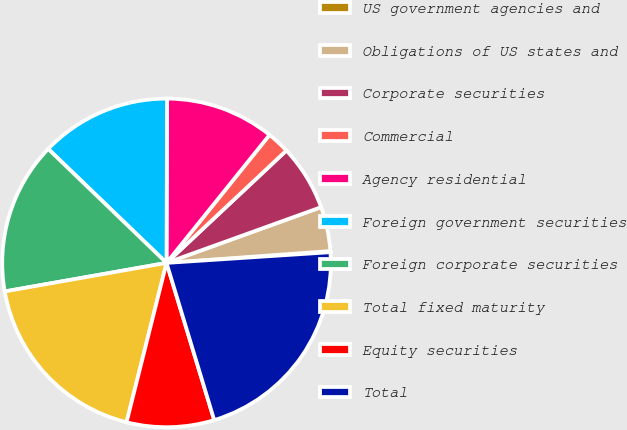<chart> <loc_0><loc_0><loc_500><loc_500><pie_chart><fcel>US government agencies and<fcel>Obligations of US states and<fcel>Corporate securities<fcel>Commercial<fcel>Agency residential<fcel>Foreign government securities<fcel>Foreign corporate securities<fcel>Total fixed maturity<fcel>Equity securities<fcel>Total<nl><fcel>0.11%<fcel>4.36%<fcel>6.48%<fcel>2.23%<fcel>10.73%<fcel>12.85%<fcel>14.98%<fcel>18.31%<fcel>8.6%<fcel>21.35%<nl></chart> 